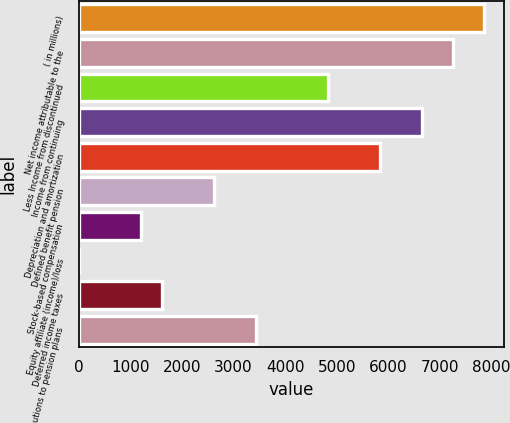<chart> <loc_0><loc_0><loc_500><loc_500><bar_chart><fcel>( in millions)<fcel>Net income attributable to the<fcel>Less Income from discontinued<fcel>Income from continuing<fcel>Depreciation and amortization<fcel>Defined benefit pension<fcel>Stock-based compensation<fcel>Equity affiliate (income)/loss<fcel>Deferred income taxes<fcel>Contributions to pension plans<nl><fcel>7854.7<fcel>7250.8<fcel>4835.2<fcel>6646.9<fcel>5841.7<fcel>2620.9<fcel>1211.8<fcel>4<fcel>1614.4<fcel>3426.1<nl></chart> 